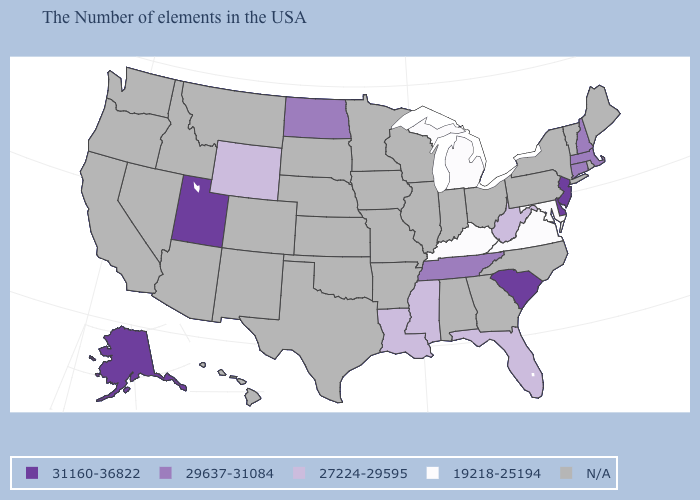What is the value of Washington?
Write a very short answer. N/A. Name the states that have a value in the range 19218-25194?
Be succinct. Maryland, Virginia, Michigan, Kentucky. What is the value of New Jersey?
Answer briefly. 31160-36822. Is the legend a continuous bar?
Keep it brief. No. Which states have the lowest value in the MidWest?
Concise answer only. Michigan. What is the value of New Hampshire?
Write a very short answer. 29637-31084. Which states have the highest value in the USA?
Short answer required. New Jersey, Delaware, South Carolina, Utah, Alaska. Among the states that border Illinois , which have the highest value?
Keep it brief. Kentucky. Among the states that border Illinois , which have the lowest value?
Quick response, please. Kentucky. What is the highest value in the USA?
Concise answer only. 31160-36822. Name the states that have a value in the range N/A?
Answer briefly. Maine, Rhode Island, Vermont, New York, Pennsylvania, North Carolina, Ohio, Georgia, Indiana, Alabama, Wisconsin, Illinois, Missouri, Arkansas, Minnesota, Iowa, Kansas, Nebraska, Oklahoma, Texas, South Dakota, Colorado, New Mexico, Montana, Arizona, Idaho, Nevada, California, Washington, Oregon, Hawaii. Name the states that have a value in the range 29637-31084?
Write a very short answer. Massachusetts, New Hampshire, Connecticut, Tennessee, North Dakota. Name the states that have a value in the range 27224-29595?
Concise answer only. West Virginia, Florida, Mississippi, Louisiana, Wyoming. Among the states that border Indiana , which have the lowest value?
Quick response, please. Michigan, Kentucky. 